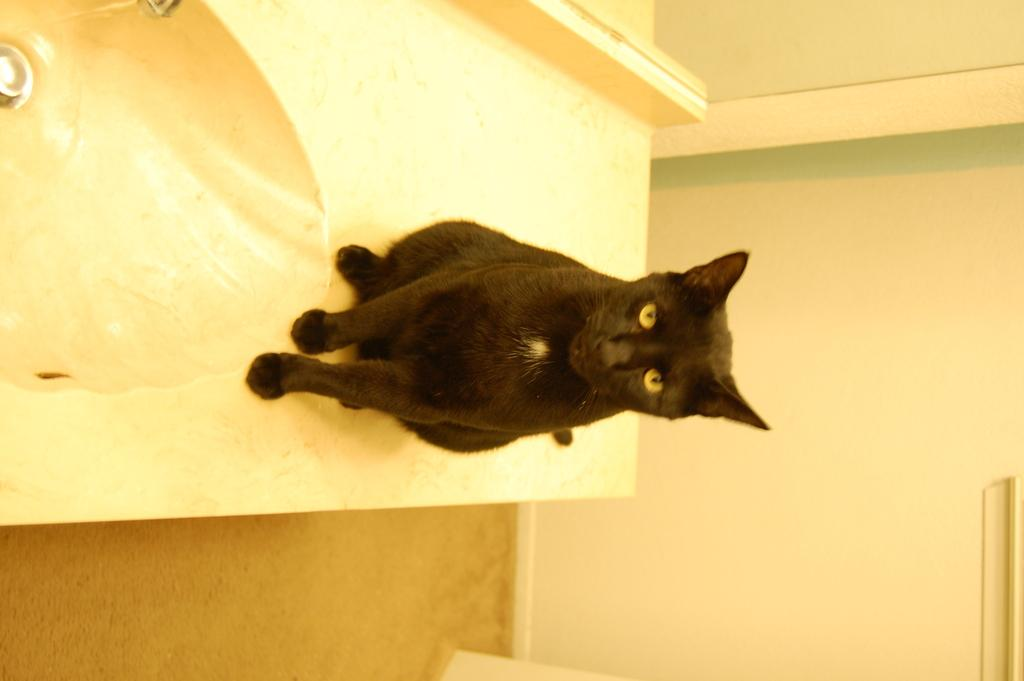What type of animal is in the image? There is a cat in the image. Where is the cat located in relation to other objects in the image? The cat is beside a sink. What can be seen on the right side of the image? There is a wall on the right side of the image. What type of hill can be seen in the background of the image? There is no hill present in the image. 